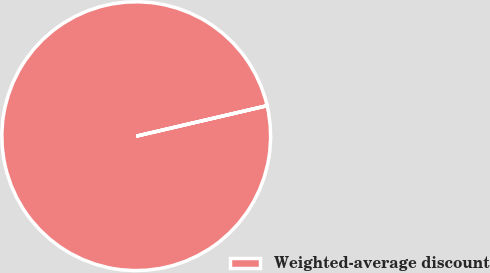Convert chart to OTSL. <chart><loc_0><loc_0><loc_500><loc_500><pie_chart><fcel>Weighted-average discount<nl><fcel>100.0%<nl></chart> 